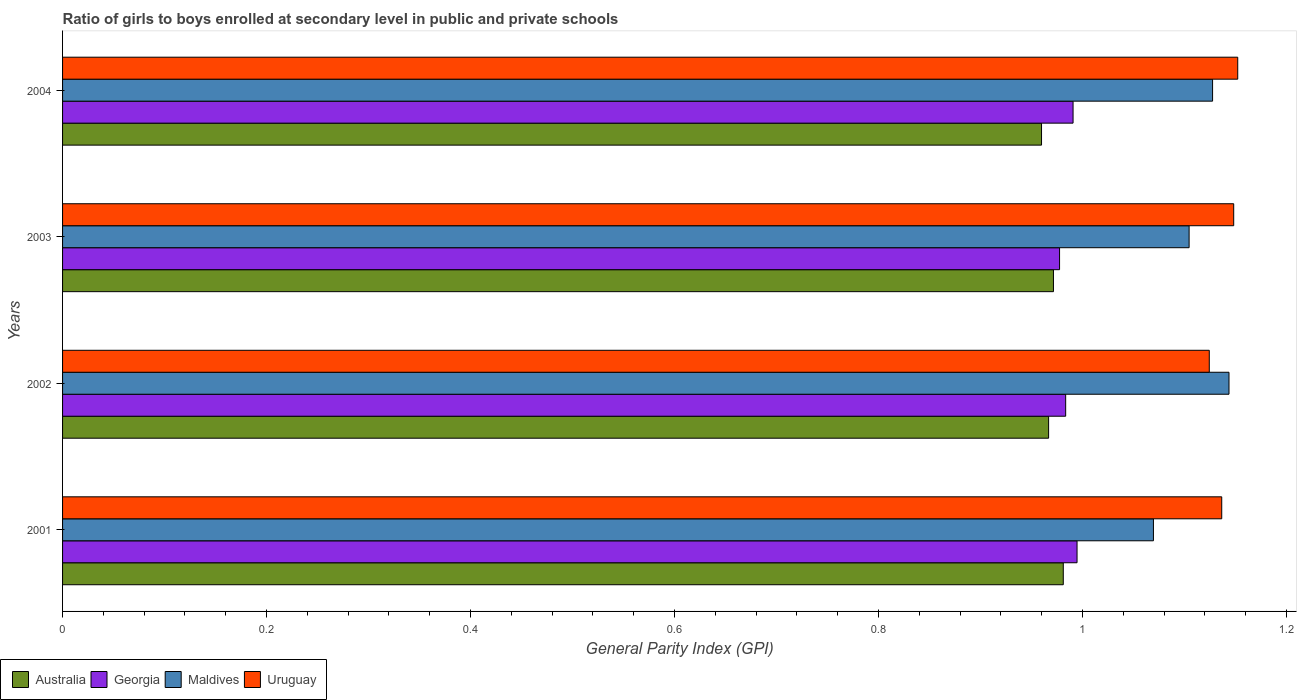Are the number of bars per tick equal to the number of legend labels?
Offer a very short reply. Yes. What is the label of the 2nd group of bars from the top?
Your response must be concise. 2003. In how many cases, is the number of bars for a given year not equal to the number of legend labels?
Your answer should be very brief. 0. What is the general parity index in Australia in 2002?
Make the answer very short. 0.97. Across all years, what is the maximum general parity index in Georgia?
Give a very brief answer. 0.99. Across all years, what is the minimum general parity index in Georgia?
Give a very brief answer. 0.98. In which year was the general parity index in Georgia minimum?
Make the answer very short. 2003. What is the total general parity index in Maldives in the graph?
Your answer should be very brief. 4.45. What is the difference between the general parity index in Maldives in 2001 and that in 2004?
Provide a succinct answer. -0.06. What is the difference between the general parity index in Maldives in 2001 and the general parity index in Georgia in 2003?
Offer a terse response. 0.09. What is the average general parity index in Maldives per year?
Make the answer very short. 1.11. In the year 2002, what is the difference between the general parity index in Maldives and general parity index in Uruguay?
Offer a terse response. 0.02. In how many years, is the general parity index in Uruguay greater than 0.7200000000000001 ?
Offer a very short reply. 4. What is the ratio of the general parity index in Uruguay in 2002 to that in 2003?
Provide a succinct answer. 0.98. Is the general parity index in Maldives in 2001 less than that in 2003?
Keep it short and to the point. Yes. Is the difference between the general parity index in Maldives in 2001 and 2002 greater than the difference between the general parity index in Uruguay in 2001 and 2002?
Make the answer very short. No. What is the difference between the highest and the second highest general parity index in Uruguay?
Offer a terse response. 0. What is the difference between the highest and the lowest general parity index in Georgia?
Offer a terse response. 0.02. Is the sum of the general parity index in Uruguay in 2003 and 2004 greater than the maximum general parity index in Australia across all years?
Ensure brevity in your answer.  Yes. Is it the case that in every year, the sum of the general parity index in Uruguay and general parity index in Georgia is greater than the sum of general parity index in Australia and general parity index in Maldives?
Provide a short and direct response. No. What does the 1st bar from the top in 2003 represents?
Give a very brief answer. Uruguay. What does the 3rd bar from the bottom in 2001 represents?
Keep it short and to the point. Maldives. Is it the case that in every year, the sum of the general parity index in Australia and general parity index in Georgia is greater than the general parity index in Maldives?
Your answer should be very brief. Yes. Are all the bars in the graph horizontal?
Offer a terse response. Yes. What is the difference between two consecutive major ticks on the X-axis?
Offer a very short reply. 0.2. Are the values on the major ticks of X-axis written in scientific E-notation?
Provide a succinct answer. No. Does the graph contain any zero values?
Your answer should be compact. No. How many legend labels are there?
Give a very brief answer. 4. How are the legend labels stacked?
Offer a very short reply. Horizontal. What is the title of the graph?
Your answer should be compact. Ratio of girls to boys enrolled at secondary level in public and private schools. What is the label or title of the X-axis?
Give a very brief answer. General Parity Index (GPI). What is the General Parity Index (GPI) in Australia in 2001?
Make the answer very short. 0.98. What is the General Parity Index (GPI) in Georgia in 2001?
Ensure brevity in your answer.  0.99. What is the General Parity Index (GPI) in Maldives in 2001?
Your response must be concise. 1.07. What is the General Parity Index (GPI) of Uruguay in 2001?
Provide a short and direct response. 1.14. What is the General Parity Index (GPI) in Australia in 2002?
Provide a succinct answer. 0.97. What is the General Parity Index (GPI) in Georgia in 2002?
Give a very brief answer. 0.98. What is the General Parity Index (GPI) of Maldives in 2002?
Offer a very short reply. 1.14. What is the General Parity Index (GPI) in Uruguay in 2002?
Offer a very short reply. 1.12. What is the General Parity Index (GPI) in Australia in 2003?
Offer a very short reply. 0.97. What is the General Parity Index (GPI) in Georgia in 2003?
Keep it short and to the point. 0.98. What is the General Parity Index (GPI) in Maldives in 2003?
Your response must be concise. 1.1. What is the General Parity Index (GPI) in Uruguay in 2003?
Give a very brief answer. 1.15. What is the General Parity Index (GPI) of Australia in 2004?
Provide a short and direct response. 0.96. What is the General Parity Index (GPI) of Georgia in 2004?
Offer a very short reply. 0.99. What is the General Parity Index (GPI) in Maldives in 2004?
Provide a short and direct response. 1.13. What is the General Parity Index (GPI) of Uruguay in 2004?
Keep it short and to the point. 1.15. Across all years, what is the maximum General Parity Index (GPI) of Australia?
Give a very brief answer. 0.98. Across all years, what is the maximum General Parity Index (GPI) of Georgia?
Keep it short and to the point. 0.99. Across all years, what is the maximum General Parity Index (GPI) in Maldives?
Provide a short and direct response. 1.14. Across all years, what is the maximum General Parity Index (GPI) of Uruguay?
Ensure brevity in your answer.  1.15. Across all years, what is the minimum General Parity Index (GPI) of Australia?
Give a very brief answer. 0.96. Across all years, what is the minimum General Parity Index (GPI) in Georgia?
Provide a short and direct response. 0.98. Across all years, what is the minimum General Parity Index (GPI) in Maldives?
Make the answer very short. 1.07. Across all years, what is the minimum General Parity Index (GPI) in Uruguay?
Your answer should be compact. 1.12. What is the total General Parity Index (GPI) in Australia in the graph?
Offer a terse response. 3.88. What is the total General Parity Index (GPI) of Georgia in the graph?
Provide a succinct answer. 3.95. What is the total General Parity Index (GPI) of Maldives in the graph?
Make the answer very short. 4.45. What is the total General Parity Index (GPI) of Uruguay in the graph?
Offer a terse response. 4.56. What is the difference between the General Parity Index (GPI) in Australia in 2001 and that in 2002?
Ensure brevity in your answer.  0.01. What is the difference between the General Parity Index (GPI) in Georgia in 2001 and that in 2002?
Your response must be concise. 0.01. What is the difference between the General Parity Index (GPI) in Maldives in 2001 and that in 2002?
Ensure brevity in your answer.  -0.07. What is the difference between the General Parity Index (GPI) in Uruguay in 2001 and that in 2002?
Ensure brevity in your answer.  0.01. What is the difference between the General Parity Index (GPI) in Australia in 2001 and that in 2003?
Offer a terse response. 0.01. What is the difference between the General Parity Index (GPI) in Georgia in 2001 and that in 2003?
Your answer should be compact. 0.02. What is the difference between the General Parity Index (GPI) in Maldives in 2001 and that in 2003?
Your answer should be compact. -0.04. What is the difference between the General Parity Index (GPI) in Uruguay in 2001 and that in 2003?
Ensure brevity in your answer.  -0.01. What is the difference between the General Parity Index (GPI) of Australia in 2001 and that in 2004?
Provide a succinct answer. 0.02. What is the difference between the General Parity Index (GPI) of Georgia in 2001 and that in 2004?
Your answer should be compact. 0. What is the difference between the General Parity Index (GPI) in Maldives in 2001 and that in 2004?
Provide a succinct answer. -0.06. What is the difference between the General Parity Index (GPI) in Uruguay in 2001 and that in 2004?
Offer a very short reply. -0.02. What is the difference between the General Parity Index (GPI) in Australia in 2002 and that in 2003?
Keep it short and to the point. -0. What is the difference between the General Parity Index (GPI) in Georgia in 2002 and that in 2003?
Your answer should be compact. 0.01. What is the difference between the General Parity Index (GPI) of Maldives in 2002 and that in 2003?
Provide a short and direct response. 0.04. What is the difference between the General Parity Index (GPI) of Uruguay in 2002 and that in 2003?
Give a very brief answer. -0.02. What is the difference between the General Parity Index (GPI) in Australia in 2002 and that in 2004?
Give a very brief answer. 0.01. What is the difference between the General Parity Index (GPI) of Georgia in 2002 and that in 2004?
Your answer should be compact. -0.01. What is the difference between the General Parity Index (GPI) in Maldives in 2002 and that in 2004?
Your answer should be compact. 0.02. What is the difference between the General Parity Index (GPI) of Uruguay in 2002 and that in 2004?
Your response must be concise. -0.03. What is the difference between the General Parity Index (GPI) of Australia in 2003 and that in 2004?
Ensure brevity in your answer.  0.01. What is the difference between the General Parity Index (GPI) of Georgia in 2003 and that in 2004?
Offer a very short reply. -0.01. What is the difference between the General Parity Index (GPI) of Maldives in 2003 and that in 2004?
Offer a terse response. -0.02. What is the difference between the General Parity Index (GPI) of Uruguay in 2003 and that in 2004?
Your answer should be compact. -0. What is the difference between the General Parity Index (GPI) of Australia in 2001 and the General Parity Index (GPI) of Georgia in 2002?
Give a very brief answer. -0. What is the difference between the General Parity Index (GPI) of Australia in 2001 and the General Parity Index (GPI) of Maldives in 2002?
Make the answer very short. -0.16. What is the difference between the General Parity Index (GPI) in Australia in 2001 and the General Parity Index (GPI) in Uruguay in 2002?
Ensure brevity in your answer.  -0.14. What is the difference between the General Parity Index (GPI) in Georgia in 2001 and the General Parity Index (GPI) in Maldives in 2002?
Your response must be concise. -0.15. What is the difference between the General Parity Index (GPI) of Georgia in 2001 and the General Parity Index (GPI) of Uruguay in 2002?
Provide a short and direct response. -0.13. What is the difference between the General Parity Index (GPI) of Maldives in 2001 and the General Parity Index (GPI) of Uruguay in 2002?
Your answer should be compact. -0.05. What is the difference between the General Parity Index (GPI) in Australia in 2001 and the General Parity Index (GPI) in Georgia in 2003?
Offer a very short reply. 0. What is the difference between the General Parity Index (GPI) of Australia in 2001 and the General Parity Index (GPI) of Maldives in 2003?
Keep it short and to the point. -0.12. What is the difference between the General Parity Index (GPI) in Australia in 2001 and the General Parity Index (GPI) in Uruguay in 2003?
Your response must be concise. -0.17. What is the difference between the General Parity Index (GPI) in Georgia in 2001 and the General Parity Index (GPI) in Maldives in 2003?
Keep it short and to the point. -0.11. What is the difference between the General Parity Index (GPI) in Georgia in 2001 and the General Parity Index (GPI) in Uruguay in 2003?
Give a very brief answer. -0.15. What is the difference between the General Parity Index (GPI) of Maldives in 2001 and the General Parity Index (GPI) of Uruguay in 2003?
Keep it short and to the point. -0.08. What is the difference between the General Parity Index (GPI) in Australia in 2001 and the General Parity Index (GPI) in Georgia in 2004?
Give a very brief answer. -0.01. What is the difference between the General Parity Index (GPI) of Australia in 2001 and the General Parity Index (GPI) of Maldives in 2004?
Offer a terse response. -0.15. What is the difference between the General Parity Index (GPI) in Australia in 2001 and the General Parity Index (GPI) in Uruguay in 2004?
Your answer should be very brief. -0.17. What is the difference between the General Parity Index (GPI) of Georgia in 2001 and the General Parity Index (GPI) of Maldives in 2004?
Provide a succinct answer. -0.13. What is the difference between the General Parity Index (GPI) of Georgia in 2001 and the General Parity Index (GPI) of Uruguay in 2004?
Give a very brief answer. -0.16. What is the difference between the General Parity Index (GPI) in Maldives in 2001 and the General Parity Index (GPI) in Uruguay in 2004?
Keep it short and to the point. -0.08. What is the difference between the General Parity Index (GPI) of Australia in 2002 and the General Parity Index (GPI) of Georgia in 2003?
Ensure brevity in your answer.  -0.01. What is the difference between the General Parity Index (GPI) in Australia in 2002 and the General Parity Index (GPI) in Maldives in 2003?
Offer a very short reply. -0.14. What is the difference between the General Parity Index (GPI) of Australia in 2002 and the General Parity Index (GPI) of Uruguay in 2003?
Your response must be concise. -0.18. What is the difference between the General Parity Index (GPI) of Georgia in 2002 and the General Parity Index (GPI) of Maldives in 2003?
Ensure brevity in your answer.  -0.12. What is the difference between the General Parity Index (GPI) of Georgia in 2002 and the General Parity Index (GPI) of Uruguay in 2003?
Provide a succinct answer. -0.16. What is the difference between the General Parity Index (GPI) of Maldives in 2002 and the General Parity Index (GPI) of Uruguay in 2003?
Provide a short and direct response. -0. What is the difference between the General Parity Index (GPI) in Australia in 2002 and the General Parity Index (GPI) in Georgia in 2004?
Offer a terse response. -0.02. What is the difference between the General Parity Index (GPI) of Australia in 2002 and the General Parity Index (GPI) of Maldives in 2004?
Offer a very short reply. -0.16. What is the difference between the General Parity Index (GPI) in Australia in 2002 and the General Parity Index (GPI) in Uruguay in 2004?
Offer a very short reply. -0.19. What is the difference between the General Parity Index (GPI) in Georgia in 2002 and the General Parity Index (GPI) in Maldives in 2004?
Your response must be concise. -0.14. What is the difference between the General Parity Index (GPI) of Georgia in 2002 and the General Parity Index (GPI) of Uruguay in 2004?
Make the answer very short. -0.17. What is the difference between the General Parity Index (GPI) in Maldives in 2002 and the General Parity Index (GPI) in Uruguay in 2004?
Ensure brevity in your answer.  -0.01. What is the difference between the General Parity Index (GPI) of Australia in 2003 and the General Parity Index (GPI) of Georgia in 2004?
Your answer should be compact. -0.02. What is the difference between the General Parity Index (GPI) of Australia in 2003 and the General Parity Index (GPI) of Maldives in 2004?
Your answer should be compact. -0.16. What is the difference between the General Parity Index (GPI) in Australia in 2003 and the General Parity Index (GPI) in Uruguay in 2004?
Offer a very short reply. -0.18. What is the difference between the General Parity Index (GPI) of Georgia in 2003 and the General Parity Index (GPI) of Maldives in 2004?
Ensure brevity in your answer.  -0.15. What is the difference between the General Parity Index (GPI) in Georgia in 2003 and the General Parity Index (GPI) in Uruguay in 2004?
Provide a succinct answer. -0.17. What is the difference between the General Parity Index (GPI) of Maldives in 2003 and the General Parity Index (GPI) of Uruguay in 2004?
Make the answer very short. -0.05. What is the average General Parity Index (GPI) in Australia per year?
Keep it short and to the point. 0.97. What is the average General Parity Index (GPI) in Georgia per year?
Your response must be concise. 0.99. What is the average General Parity Index (GPI) in Maldives per year?
Offer a very short reply. 1.11. What is the average General Parity Index (GPI) in Uruguay per year?
Your answer should be compact. 1.14. In the year 2001, what is the difference between the General Parity Index (GPI) of Australia and General Parity Index (GPI) of Georgia?
Ensure brevity in your answer.  -0.01. In the year 2001, what is the difference between the General Parity Index (GPI) of Australia and General Parity Index (GPI) of Maldives?
Offer a terse response. -0.09. In the year 2001, what is the difference between the General Parity Index (GPI) of Australia and General Parity Index (GPI) of Uruguay?
Offer a very short reply. -0.16. In the year 2001, what is the difference between the General Parity Index (GPI) in Georgia and General Parity Index (GPI) in Maldives?
Offer a very short reply. -0.07. In the year 2001, what is the difference between the General Parity Index (GPI) of Georgia and General Parity Index (GPI) of Uruguay?
Ensure brevity in your answer.  -0.14. In the year 2001, what is the difference between the General Parity Index (GPI) of Maldives and General Parity Index (GPI) of Uruguay?
Offer a terse response. -0.07. In the year 2002, what is the difference between the General Parity Index (GPI) in Australia and General Parity Index (GPI) in Georgia?
Your response must be concise. -0.02. In the year 2002, what is the difference between the General Parity Index (GPI) of Australia and General Parity Index (GPI) of Maldives?
Offer a terse response. -0.18. In the year 2002, what is the difference between the General Parity Index (GPI) in Australia and General Parity Index (GPI) in Uruguay?
Make the answer very short. -0.16. In the year 2002, what is the difference between the General Parity Index (GPI) in Georgia and General Parity Index (GPI) in Maldives?
Give a very brief answer. -0.16. In the year 2002, what is the difference between the General Parity Index (GPI) of Georgia and General Parity Index (GPI) of Uruguay?
Offer a very short reply. -0.14. In the year 2002, what is the difference between the General Parity Index (GPI) of Maldives and General Parity Index (GPI) of Uruguay?
Ensure brevity in your answer.  0.02. In the year 2003, what is the difference between the General Parity Index (GPI) in Australia and General Parity Index (GPI) in Georgia?
Your answer should be very brief. -0.01. In the year 2003, what is the difference between the General Parity Index (GPI) of Australia and General Parity Index (GPI) of Maldives?
Your answer should be compact. -0.13. In the year 2003, what is the difference between the General Parity Index (GPI) in Australia and General Parity Index (GPI) in Uruguay?
Your answer should be compact. -0.18. In the year 2003, what is the difference between the General Parity Index (GPI) of Georgia and General Parity Index (GPI) of Maldives?
Provide a short and direct response. -0.13. In the year 2003, what is the difference between the General Parity Index (GPI) in Georgia and General Parity Index (GPI) in Uruguay?
Offer a very short reply. -0.17. In the year 2003, what is the difference between the General Parity Index (GPI) in Maldives and General Parity Index (GPI) in Uruguay?
Ensure brevity in your answer.  -0.04. In the year 2004, what is the difference between the General Parity Index (GPI) of Australia and General Parity Index (GPI) of Georgia?
Offer a very short reply. -0.03. In the year 2004, what is the difference between the General Parity Index (GPI) of Australia and General Parity Index (GPI) of Maldives?
Provide a short and direct response. -0.17. In the year 2004, what is the difference between the General Parity Index (GPI) in Australia and General Parity Index (GPI) in Uruguay?
Offer a very short reply. -0.19. In the year 2004, what is the difference between the General Parity Index (GPI) in Georgia and General Parity Index (GPI) in Maldives?
Give a very brief answer. -0.14. In the year 2004, what is the difference between the General Parity Index (GPI) of Georgia and General Parity Index (GPI) of Uruguay?
Provide a succinct answer. -0.16. In the year 2004, what is the difference between the General Parity Index (GPI) in Maldives and General Parity Index (GPI) in Uruguay?
Give a very brief answer. -0.02. What is the ratio of the General Parity Index (GPI) of Australia in 2001 to that in 2002?
Ensure brevity in your answer.  1.01. What is the ratio of the General Parity Index (GPI) of Georgia in 2001 to that in 2002?
Ensure brevity in your answer.  1.01. What is the ratio of the General Parity Index (GPI) in Maldives in 2001 to that in 2002?
Ensure brevity in your answer.  0.94. What is the ratio of the General Parity Index (GPI) in Uruguay in 2001 to that in 2002?
Provide a short and direct response. 1.01. What is the ratio of the General Parity Index (GPI) in Australia in 2001 to that in 2003?
Offer a terse response. 1.01. What is the ratio of the General Parity Index (GPI) in Georgia in 2001 to that in 2003?
Offer a terse response. 1.02. What is the ratio of the General Parity Index (GPI) of Maldives in 2001 to that in 2003?
Provide a succinct answer. 0.97. What is the ratio of the General Parity Index (GPI) in Australia in 2001 to that in 2004?
Your response must be concise. 1.02. What is the ratio of the General Parity Index (GPI) of Georgia in 2001 to that in 2004?
Give a very brief answer. 1. What is the ratio of the General Parity Index (GPI) in Maldives in 2001 to that in 2004?
Offer a very short reply. 0.95. What is the ratio of the General Parity Index (GPI) in Uruguay in 2001 to that in 2004?
Keep it short and to the point. 0.99. What is the ratio of the General Parity Index (GPI) of Maldives in 2002 to that in 2003?
Provide a short and direct response. 1.04. What is the ratio of the General Parity Index (GPI) in Uruguay in 2002 to that in 2003?
Your answer should be very brief. 0.98. What is the ratio of the General Parity Index (GPI) of Maldives in 2002 to that in 2004?
Ensure brevity in your answer.  1.01. What is the ratio of the General Parity Index (GPI) of Uruguay in 2002 to that in 2004?
Keep it short and to the point. 0.98. What is the ratio of the General Parity Index (GPI) in Australia in 2003 to that in 2004?
Make the answer very short. 1.01. What is the ratio of the General Parity Index (GPI) in Georgia in 2003 to that in 2004?
Make the answer very short. 0.99. What is the ratio of the General Parity Index (GPI) of Maldives in 2003 to that in 2004?
Offer a very short reply. 0.98. What is the ratio of the General Parity Index (GPI) in Uruguay in 2003 to that in 2004?
Ensure brevity in your answer.  1. What is the difference between the highest and the second highest General Parity Index (GPI) of Australia?
Provide a short and direct response. 0.01. What is the difference between the highest and the second highest General Parity Index (GPI) in Georgia?
Provide a short and direct response. 0. What is the difference between the highest and the second highest General Parity Index (GPI) in Maldives?
Offer a terse response. 0.02. What is the difference between the highest and the second highest General Parity Index (GPI) in Uruguay?
Your answer should be compact. 0. What is the difference between the highest and the lowest General Parity Index (GPI) in Australia?
Offer a very short reply. 0.02. What is the difference between the highest and the lowest General Parity Index (GPI) of Georgia?
Provide a short and direct response. 0.02. What is the difference between the highest and the lowest General Parity Index (GPI) of Maldives?
Provide a short and direct response. 0.07. What is the difference between the highest and the lowest General Parity Index (GPI) of Uruguay?
Offer a very short reply. 0.03. 